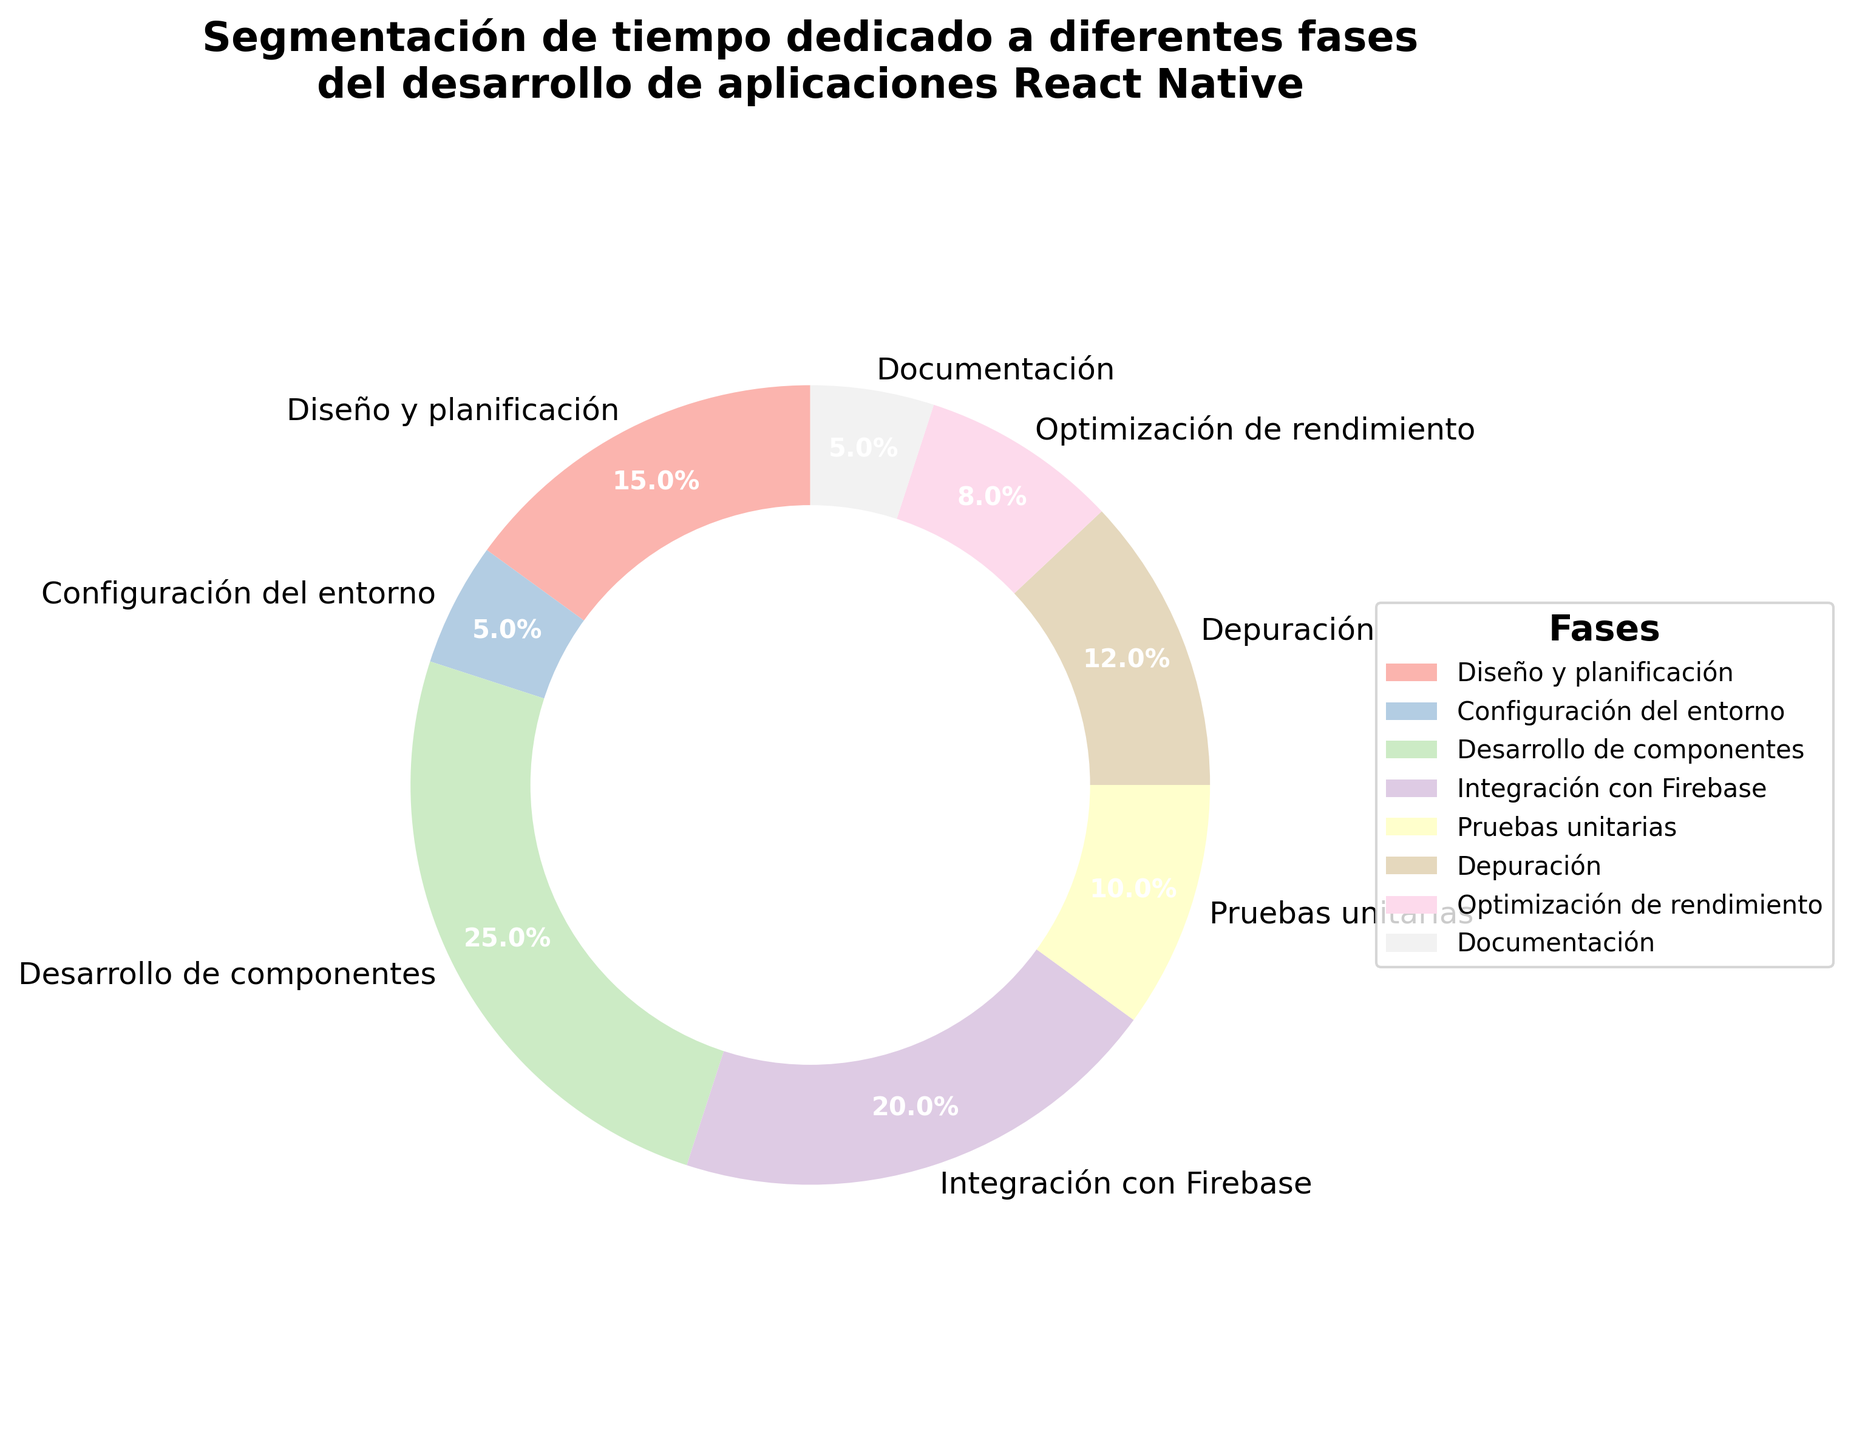Which phase takes the largest percentage of time? The phase with the largest percentage is the one with the highest value in the pie chart. Here, "Desarrollo de componentes" takes the largest percentage of time with 25%.
Answer: Desarrollo de componentes What is the total percentage of time spent on "Diseño y planificación" and "Pruebas unitarias"? Add the percentage values for "Diseño y planificación" (15%) and "Pruebas unitarias" (10%). So, 15 + 10 = 25.
Answer: 25% How much more time is spent on "Desarrollo de componentes" than on "Depuración"? Subtract the percentage for "Depuración" (12%) from "Desarrollo de componentes" (25%). So, 25 - 12 = 13.
Answer: 13% What is the combined percentage for "Configuración del entorno", "Documentación", and "Optimización de rendimiento"? Add the percentages for "Configuración del entorno" (5%), "Documentación" (5%), and "Optimización de rendimiento" (8%). So, 5 + 5 + 8 = 18.
Answer: 18% Which phase takes the least time? Identify the phase with the lowest percentage value on the pie chart. "Configuración del entorno" and "Documentación" both take the least time at 5%.
Answer: Configuración del entorno, Documentación Is the time spent on "Integración con Firebase" greater than the combined time spent on "Diseño y planificación" and "Depuración"? Compare the percentage for "Integración con Firebase" (20%) with the combined percentage for "Diseño y planificación" (15%) and "Depuración" (12%). So, 15 + 12 = 27; 20 is not greater than 27.
Answer: No How much time is spent on "Optimización de rendimiento" compared to "Pruebas unitarias"? Compare the percentages directly. "Optimización de rendimiento" is 8% and "Pruebas unitarias" is 10%. Since 8 is less than 10, less time is spent on "Optimización de rendimiento".
Answer: Less What percentage of time is not spent on "Desarrollo de componentes"? Subtract the percentage of "Desarrollo de componentes" (25%) from 100%. So, 100 - 25 = 75.
Answer: 75% Which phases together account for 22% of the total time? Identify phases whose combined percentages equal 22%. "Pruebas unitarias" (10%) and "Depuración" (12%) together account for 22%.
Answer: Pruebas unitarias, Depuración What is the difference between the time spent on "Optimización de rendimiento" and "Configuración del entorno"? Subtract the percentage for "Configuración del entorno" (5%) from "Optimización de rendimiento" (8%). So, 8 - 5 = 3.
Answer: 3% 